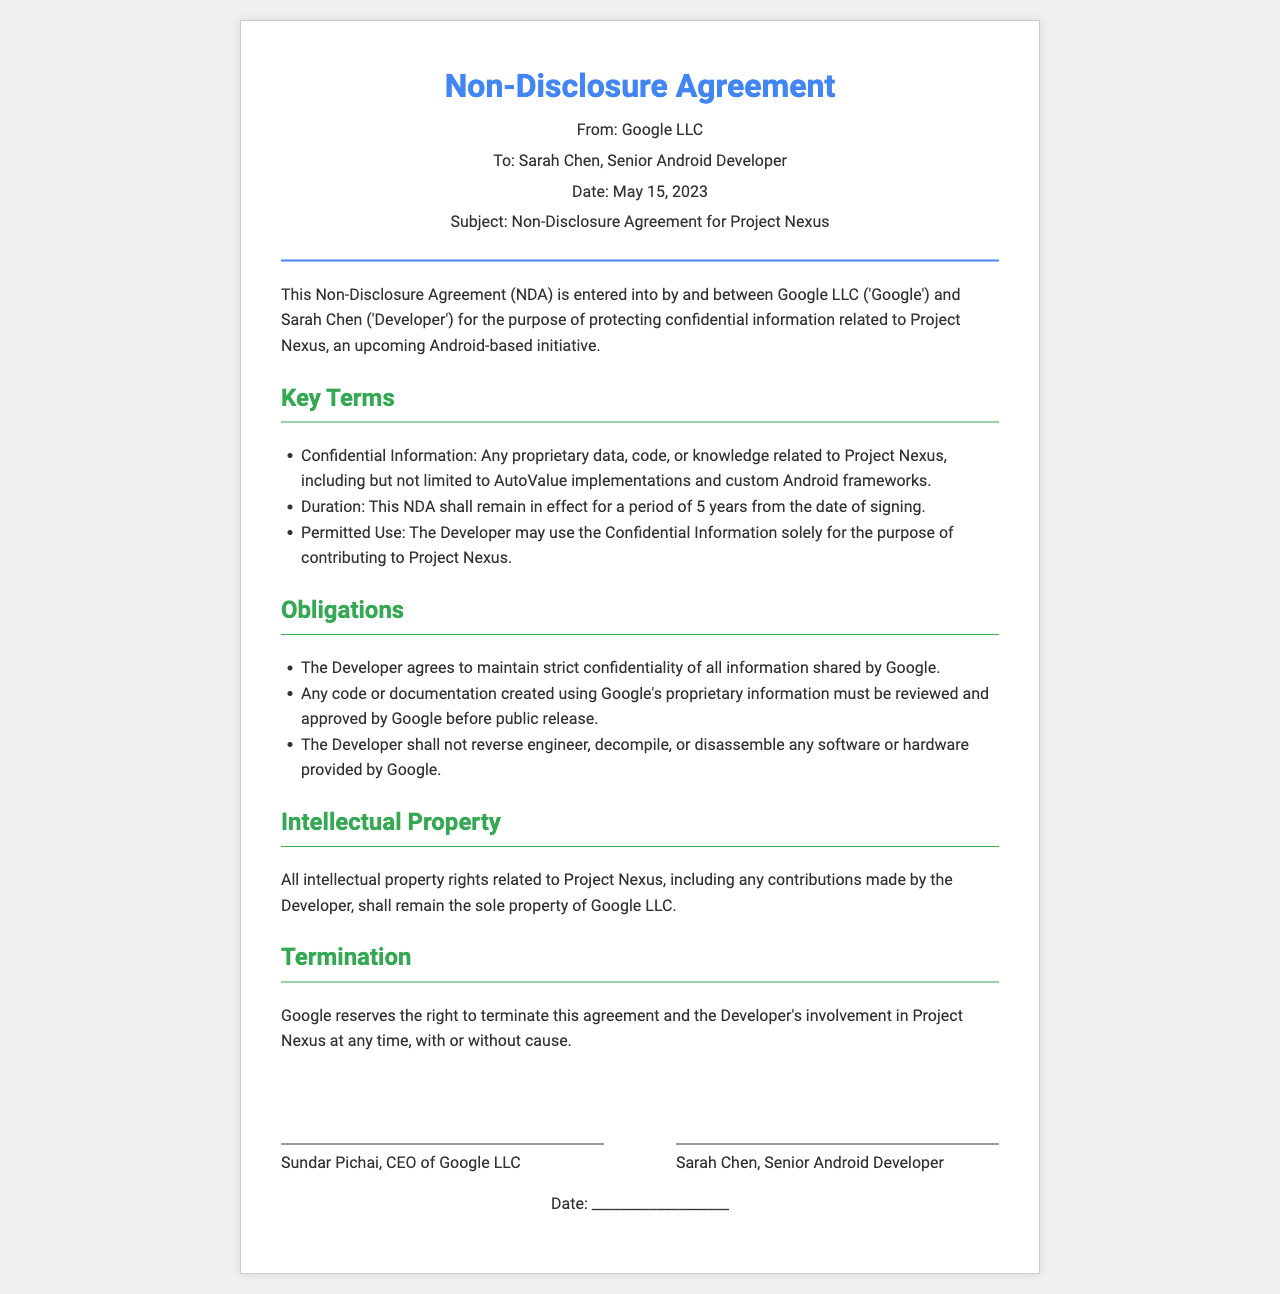What is the sender's name? The sender is identified at the top of the document as Google LLC.
Answer: Google LLC What is the recipient's name? The recipient is mentioned in the header section as Sarah Chen.
Answer: Sarah Chen What is the date of the fax? The date is provided in the header section of the document as May 15, 2023.
Answer: May 15, 2023 What is the duration of the NDA? The duration is specified in the document as 5 years from the date of signing.
Answer: 5 years What must the Developer agree to undertake regarding the confidentiality? The Developer agrees to maintain strict confidentiality of all information shared by Google.
Answer: strict confidentiality What rights do the intellectual property contributions belong to? The document indicates that all intellectual property rights belong solely to Google LLC.
Answer: Google LLC What is one obligation of the Developer regarding the proprietary information? The Developer must have any code reviewed and approved before public release.
Answer: reviewed and approved Who is the CEO of Google LLC? The signature block indicates that Sundar Pichai is the CEO of Google LLC.
Answer: Sundar Pichai What can Google do regarding the agreement? Google reserves the right to terminate this agreement at any time.
Answer: terminate this agreement 